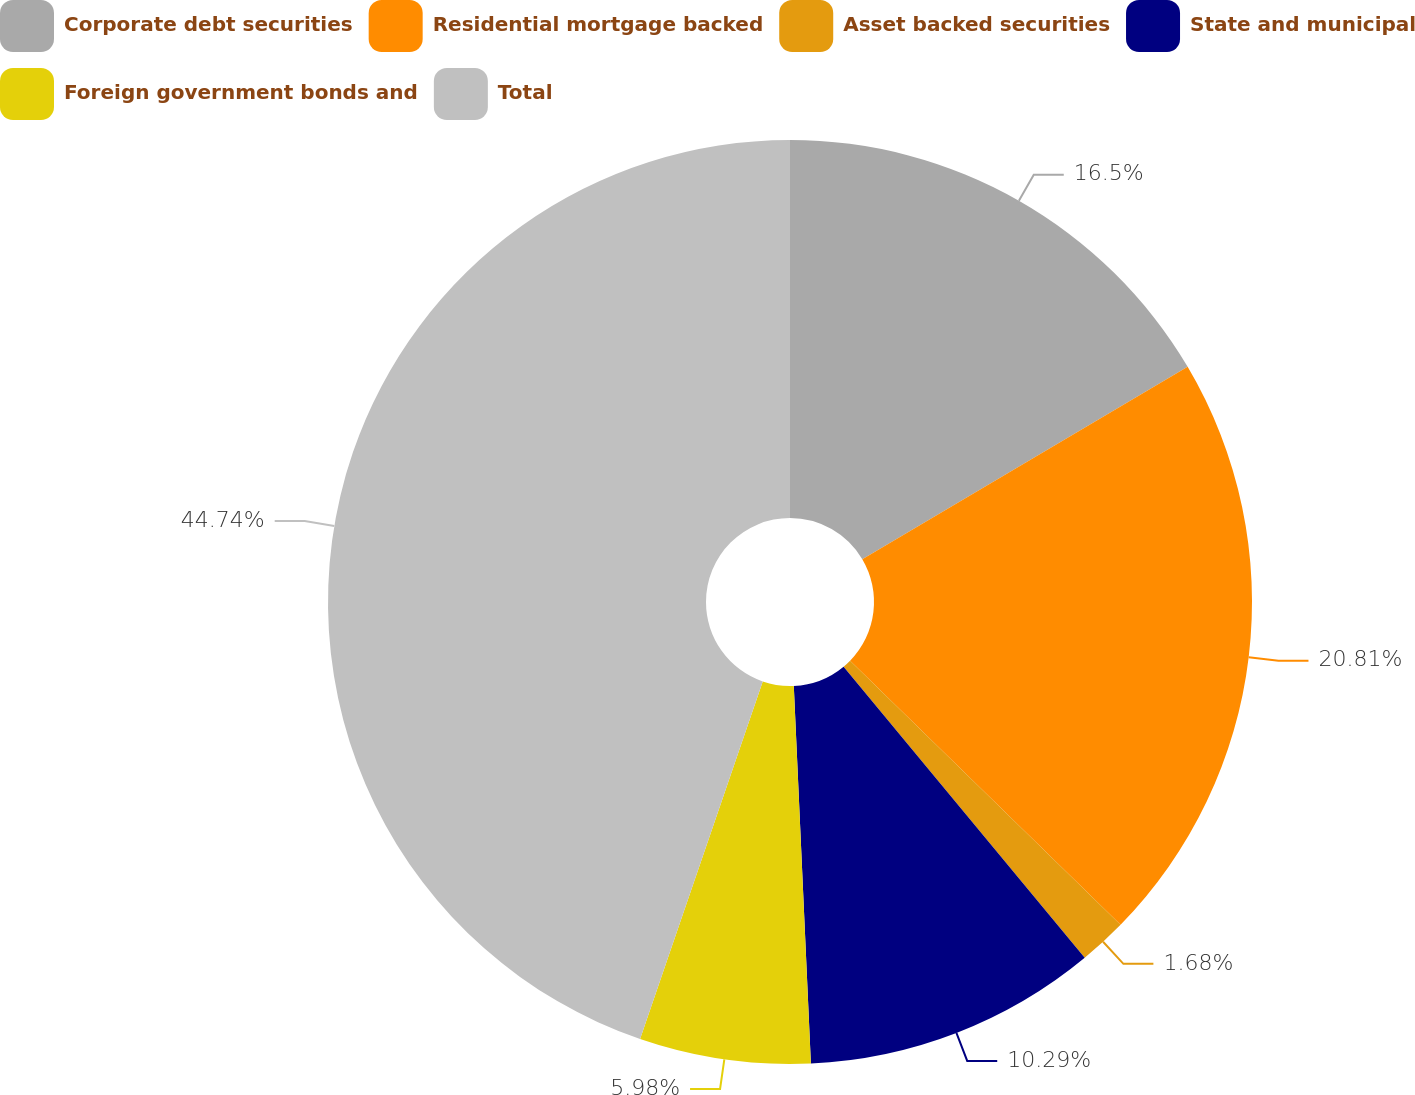<chart> <loc_0><loc_0><loc_500><loc_500><pie_chart><fcel>Corporate debt securities<fcel>Residential mortgage backed<fcel>Asset backed securities<fcel>State and municipal<fcel>Foreign government bonds and<fcel>Total<nl><fcel>16.5%<fcel>20.81%<fcel>1.68%<fcel>10.29%<fcel>5.98%<fcel>44.74%<nl></chart> 